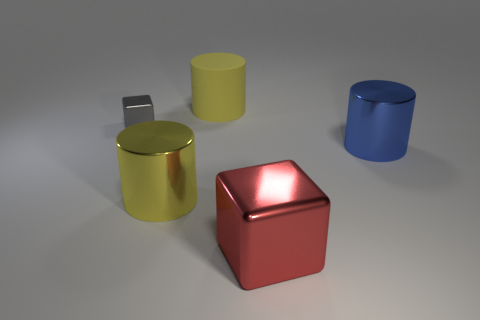Are there any other things that have the same size as the gray cube?
Your answer should be compact. No. There is a large cylinder that is the same color as the big rubber thing; what material is it?
Keep it short and to the point. Metal. Does the yellow rubber cylinder have the same size as the gray thing?
Provide a succinct answer. No. There is a big yellow object in front of the tiny gray object; are there any tiny shiny things right of it?
Make the answer very short. No. There is a metallic object that is in front of the big yellow metallic cylinder; what shape is it?
Offer a very short reply. Cube. There is a shiny cube that is behind the block in front of the large blue cylinder; what number of tiny gray shiny cubes are right of it?
Give a very brief answer. 0. Is the size of the red shiny block the same as the shiny object right of the big cube?
Make the answer very short. Yes. What size is the yellow metallic cylinder that is in front of the cube that is on the left side of the big yellow rubber thing?
Offer a very short reply. Large. How many big red things have the same material as the red cube?
Your response must be concise. 0. Is there a large purple rubber cylinder?
Your answer should be compact. No. 